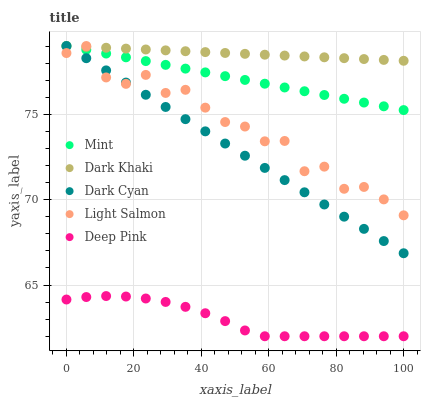Does Deep Pink have the minimum area under the curve?
Answer yes or no. Yes. Does Dark Khaki have the maximum area under the curve?
Answer yes or no. Yes. Does Dark Cyan have the minimum area under the curve?
Answer yes or no. No. Does Dark Cyan have the maximum area under the curve?
Answer yes or no. No. Is Dark Khaki the smoothest?
Answer yes or no. Yes. Is Light Salmon the roughest?
Answer yes or no. Yes. Is Dark Cyan the smoothest?
Answer yes or no. No. Is Dark Cyan the roughest?
Answer yes or no. No. Does Deep Pink have the lowest value?
Answer yes or no. Yes. Does Dark Cyan have the lowest value?
Answer yes or no. No. Does Mint have the highest value?
Answer yes or no. Yes. Does Deep Pink have the highest value?
Answer yes or no. No. Is Deep Pink less than Dark Cyan?
Answer yes or no. Yes. Is Light Salmon greater than Deep Pink?
Answer yes or no. Yes. Does Mint intersect Dark Khaki?
Answer yes or no. Yes. Is Mint less than Dark Khaki?
Answer yes or no. No. Is Mint greater than Dark Khaki?
Answer yes or no. No. Does Deep Pink intersect Dark Cyan?
Answer yes or no. No. 